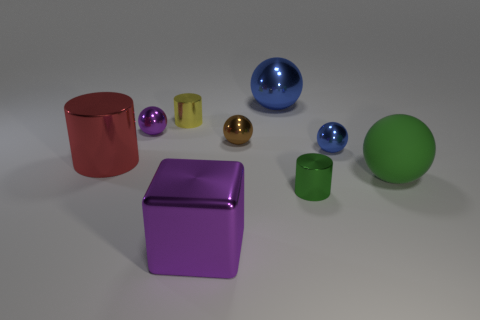Do the big red thing and the blue ball that is on the left side of the green cylinder have the same material? While both the big red object, which appears to be a glossy cylinder, and the blue sphere have reflective surfaces, it is difficult to determine with absolute certainty if they are made of the same material without further context. However, based on the visual properties such as the shine and reflection, they may indeed be constructed from similar materials with a high gloss finish. 